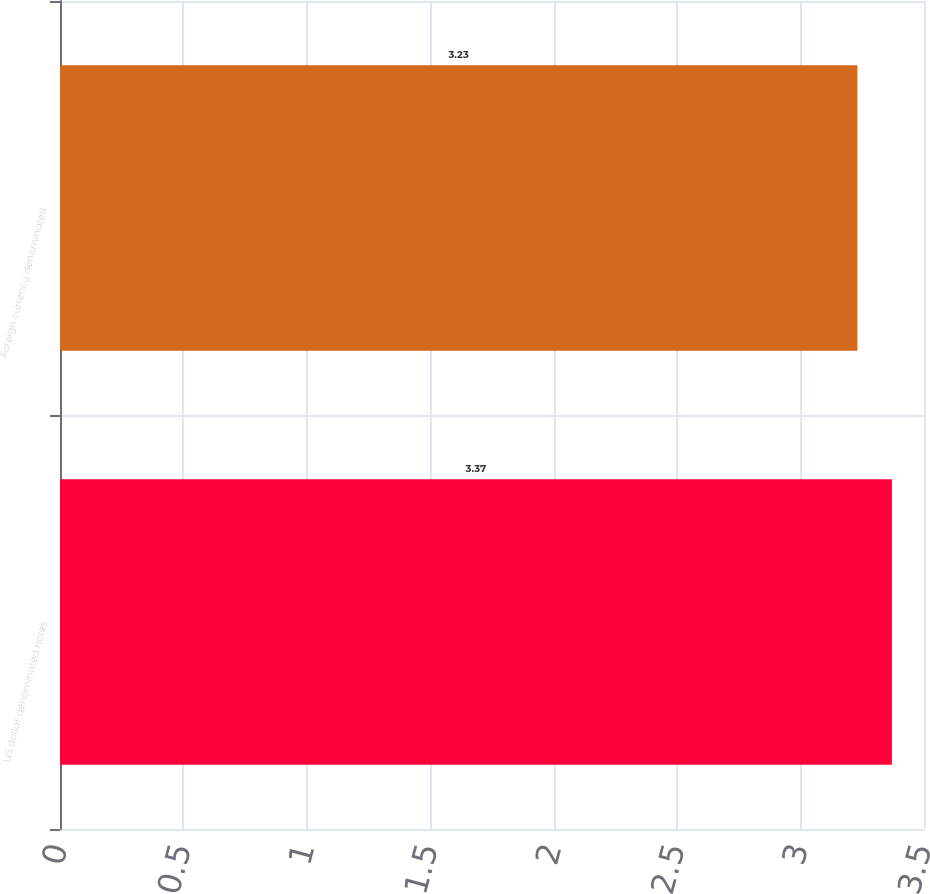<chart> <loc_0><loc_0><loc_500><loc_500><bar_chart><fcel>US dollar denominated notes<fcel>Foreign currency denominated<nl><fcel>3.37<fcel>3.23<nl></chart> 